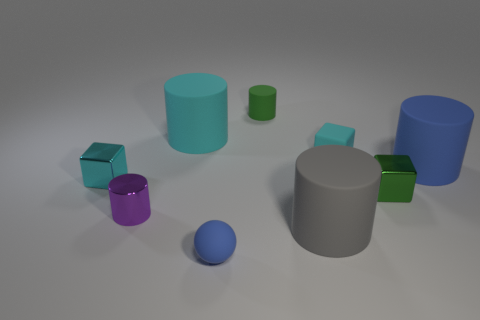Subtract 1 cylinders. How many cylinders are left? 4 Subtract all red cylinders. Subtract all gray blocks. How many cylinders are left? 5 Subtract all blocks. How many objects are left? 6 Subtract 0 yellow blocks. How many objects are left? 9 Subtract all large cyan objects. Subtract all tiny shiny things. How many objects are left? 5 Add 8 large cyan rubber cylinders. How many large cyan rubber cylinders are left? 9 Add 8 small green metallic cubes. How many small green metallic cubes exist? 9 